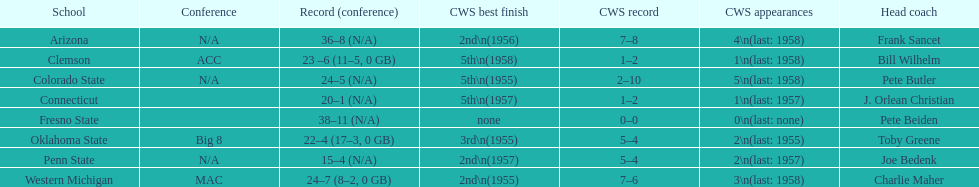Does clemson or western michigan have more cws appearances? Western Michigan. 